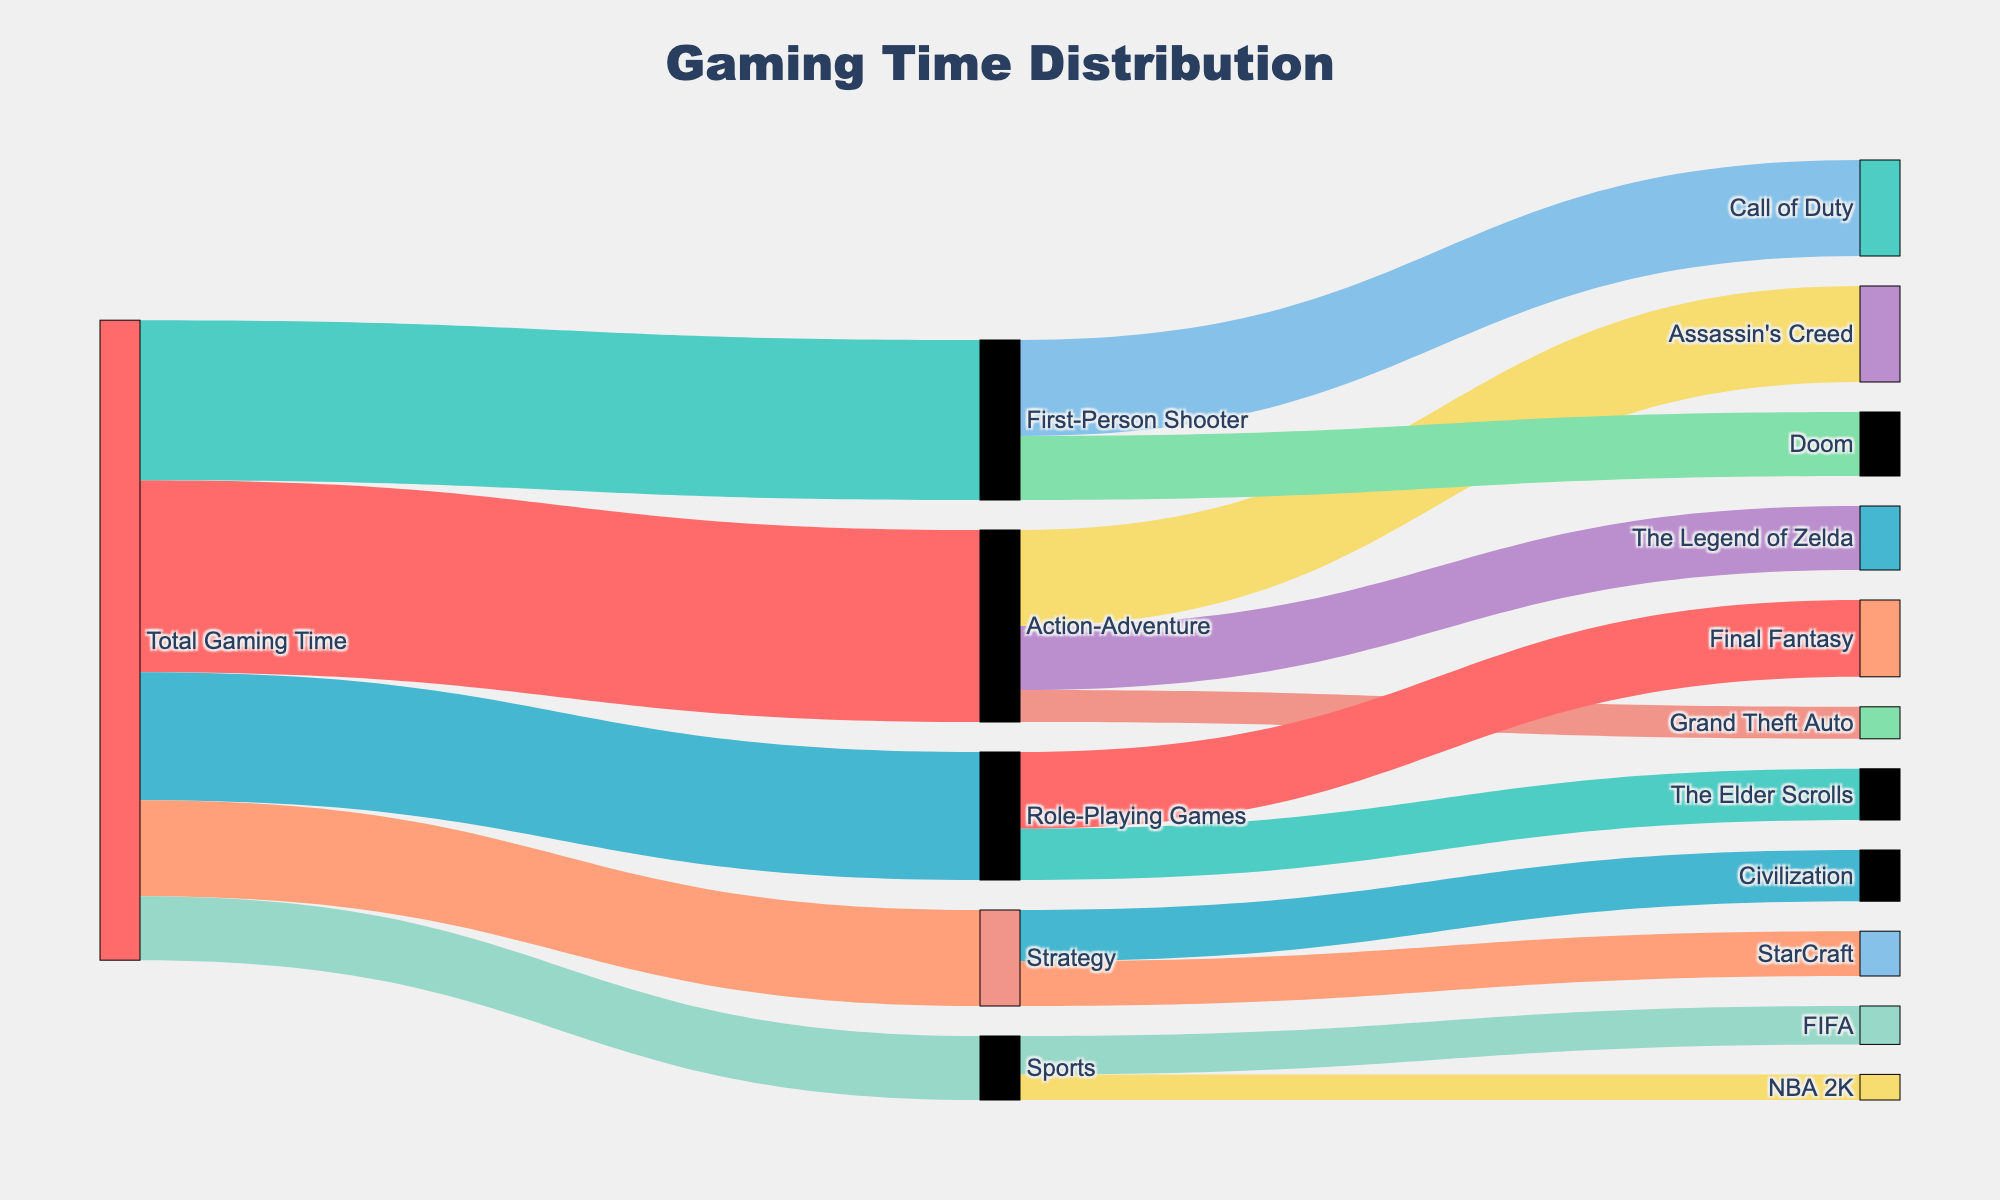What is the title of the figure? The title of the figure is displayed at the top-center of the plot. It reads "Gaming Time Distribution" as specified in the figure’s properties.
Answer: Gaming Time Distribution Which genre has the highest gaming time? To find the genre with the highest gaming time, look at the first set of outgoing connections from "Total Gaming Time." The "Action-Adventure" genre has the largest value associated with it.
Answer: Action-Adventure How much total gaming time is spent on "The Legend of Zelda"? To find this, look at the connections stemming from "Action-Adventure" and find "The Legend of Zelda." The value associated with it is 10.
Answer: 10 What is the combined gaming time for "First-Person Shooter" games? Sum the values of all games listed under "First-Person Shooter." The values are 15 for "Call of Duty" and 10 for "Doom." Adding these together gives 15 + 10.
Answer: 25 Which individual game has the lowest reported gaming time? Look for the smallest value among all the individual games listed. "Grand Theft Auto" under "Action-Adventure" has the smallest value with 5.
Answer: Grand Theft Auto How does the gaming time for "FIFA" compare to "NBA 2K"? Check the values associated with "FIFA" and "NBA 2K" under the "Sports" category. "FIFA" has a value of 6, while "NBA 2K" has a value of 4.
Answer: FIFA has more gaming time than NBA 2K What percentage of total gaming time is spent on "Strategy" games? The total gaming time is the sum of all gaming times listed: 30 + 25 + 20 + 15 + 10 = 100. The "Strategy" category has a total of 15. To find the percentage: (15/100) * 100 = 15%.
Answer: 15% How many games are included in the "Role-Playing Games" genre? Look at all the connections from "Role-Playing Games." The genre includes "Final Fantasy" and "The Elder Scrolls."
Answer: 2 How does the total time spent on "Civilization" compare with "StarCraft"? Check the values for both games under the "Strategy" category. "Civilization" has 8, and "StarCraft" has 7. Therefore, "Civilization" has more time spent than "StarCraft."
Answer: Civilization has more gaming time than StarCraft What is the combined gaming time for "Assassin's Creed," "Doom," and "Final Fantasy"? Sum the values for each of the listed games: "Assassin's Creed" (15), "Doom" (10), and "Final Fantasy" (12). The total is 15 + 10 + 12 = 37.
Answer: 37 